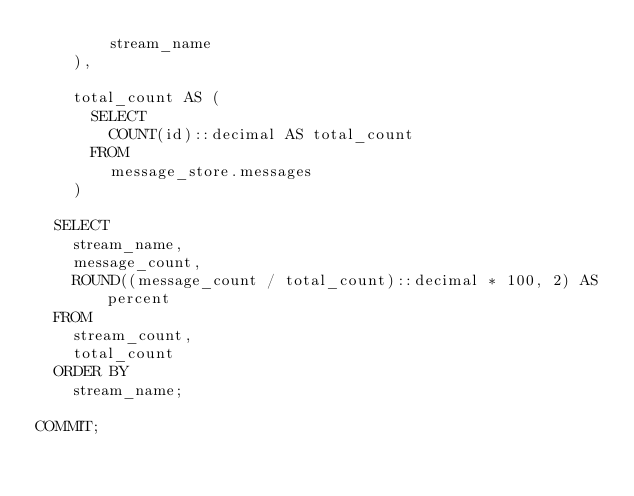Convert code to text. <code><loc_0><loc_0><loc_500><loc_500><_SQL_>        stream_name
    ),

    total_count AS (
      SELECT
        COUNT(id)::decimal AS total_count
      FROM
        message_store.messages
    )

  SELECT
    stream_name,
    message_count,
    ROUND((message_count / total_count)::decimal * 100, 2) AS percent
  FROM
    stream_count,
    total_count
  ORDER BY
    stream_name;

COMMIT;
</code> 